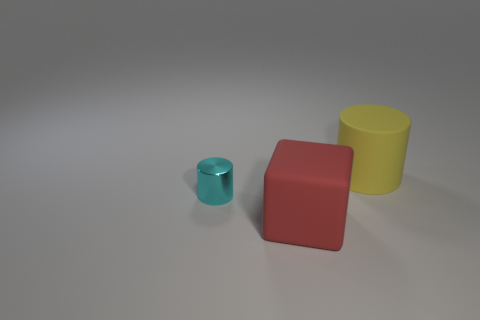Add 2 big rubber cylinders. How many objects exist? 5 Subtract all cubes. How many objects are left? 2 Add 3 large red objects. How many large red objects exist? 4 Subtract 0 green cylinders. How many objects are left? 3 Subtract all cyan shiny cylinders. Subtract all large yellow things. How many objects are left? 1 Add 2 big yellow rubber things. How many big yellow rubber things are left? 3 